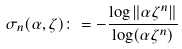<formula> <loc_0><loc_0><loc_500><loc_500>\sigma _ { n } ( \alpha , \zeta ) \colon = - \frac { \log \| \alpha \zeta ^ { n } \| } { \log ( \alpha \zeta ^ { n } ) }</formula> 